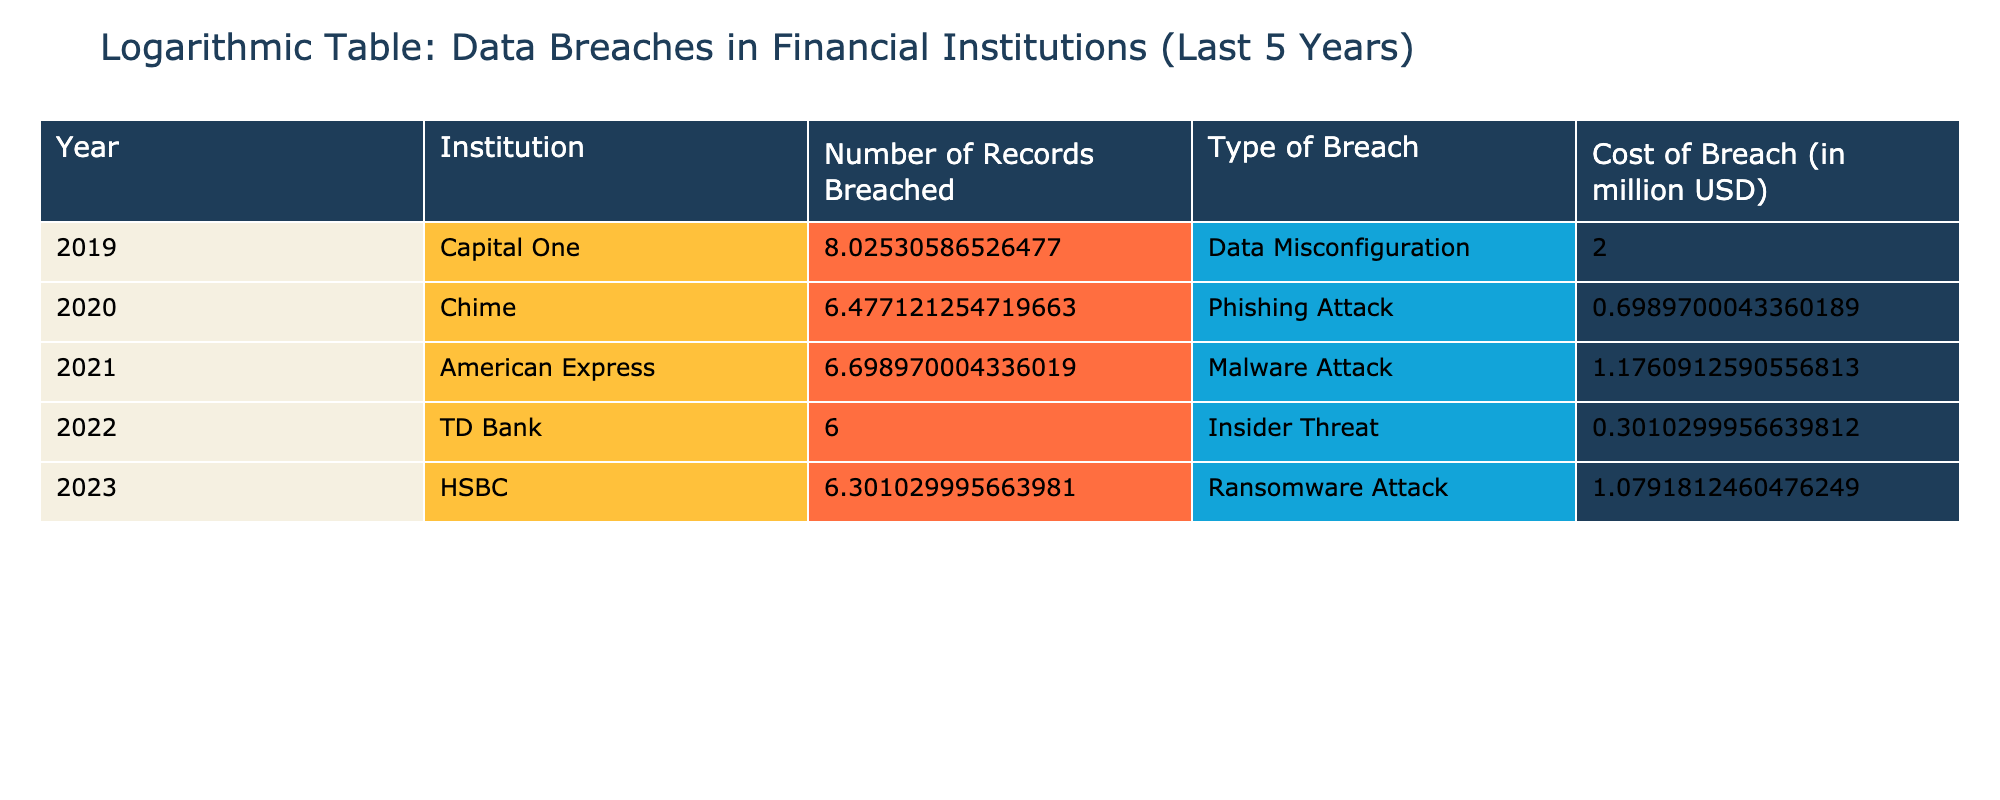What was the cost of the breach for Capital One? The table shows that the cost of the breach for Capital One in 2019 was 100 million USD.
Answer: 100 million USD Which institution had the highest number of records breached? By looking at the "Number of Records Breached" column, Capital One had the highest at 106,000,000 records breached in 2019.
Answer: Capital One Did any institution experience a breach due to an insider threat? Yes, the table states that TD Bank experienced an insider threat breach in 2022.
Answer: Yes What is the average cost of breaches from 2020 to 2023? First, we identify the costs from each year: 5 (Chime) + 15 (American Express) + 2 (TD Bank) + 12 (HSBC) = 34 million USD. Then, we divide by 4 (the number of institutions from these years) for the average: 34 / 4 = 8.5 million USD.
Answer: 8.5 million USD How many records were breached in total across all the institutions listed? Adding together the number of records breached from each entry: 106,000,000 (Capital One) + 3,000,000 (Chime) + 5,000,000 (American Express) + 1,000,000 (TD Bank) + 2,000,000 (HSBC) gives 117,000,000 total records breached.
Answer: 117,000,000 Was the total number of records breached in 2022 higher or lower than that in 2020? TD Bank had 1,000,000 records breached in 2022 and Chime had 3,000,000 in 2020, which means 1,000,000 is lower than 3,000,000.
Answer: Lower Which type of breach occurred at HSBC? According to the table, HSBC experienced a ransomware attack in 2023.
Answer: Ransomware Attack What is the logarithmic transformation of the records breached for American Express? The number of records breached for American Express was 5,000,000. The logarithmic transformation is log10(5,000,000) ≈ 6.699.
Answer: Approximately 6.699 What institution had the least cost associated with a breach? The lowest cost of breach according to the table is TD Bank with 2 million USD in 2022.
Answer: TD Bank 